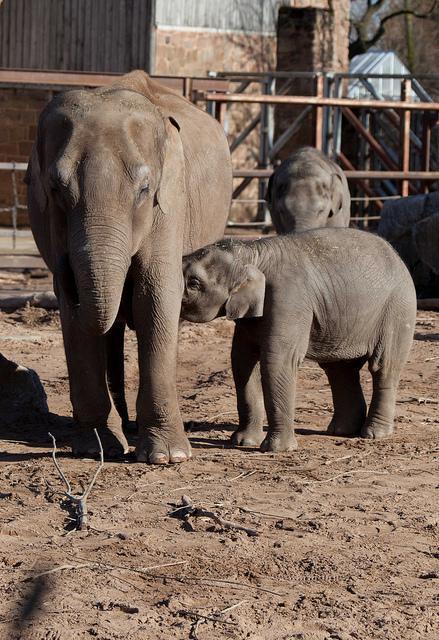How many different sizes of elephants are visible?
Give a very brief answer. 3. How many elephants are there?
Give a very brief answer. 4. 